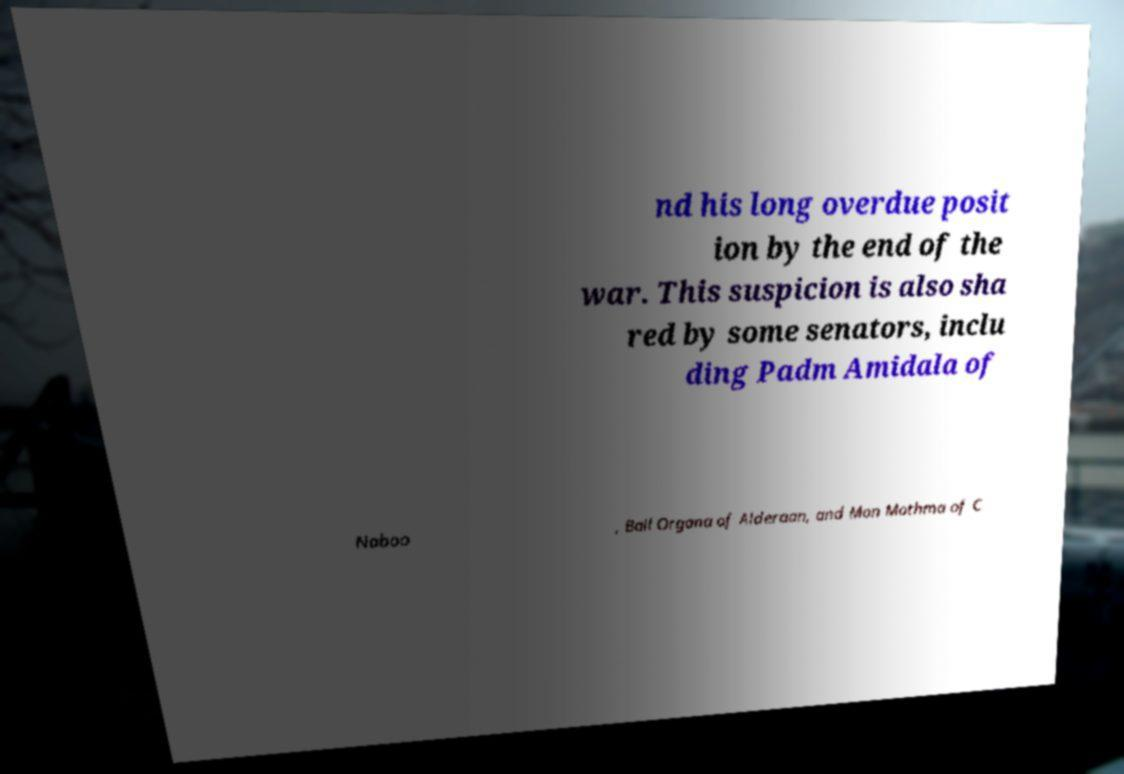Could you assist in decoding the text presented in this image and type it out clearly? nd his long overdue posit ion by the end of the war. This suspicion is also sha red by some senators, inclu ding Padm Amidala of Naboo , Bail Organa of Alderaan, and Mon Mothma of C 